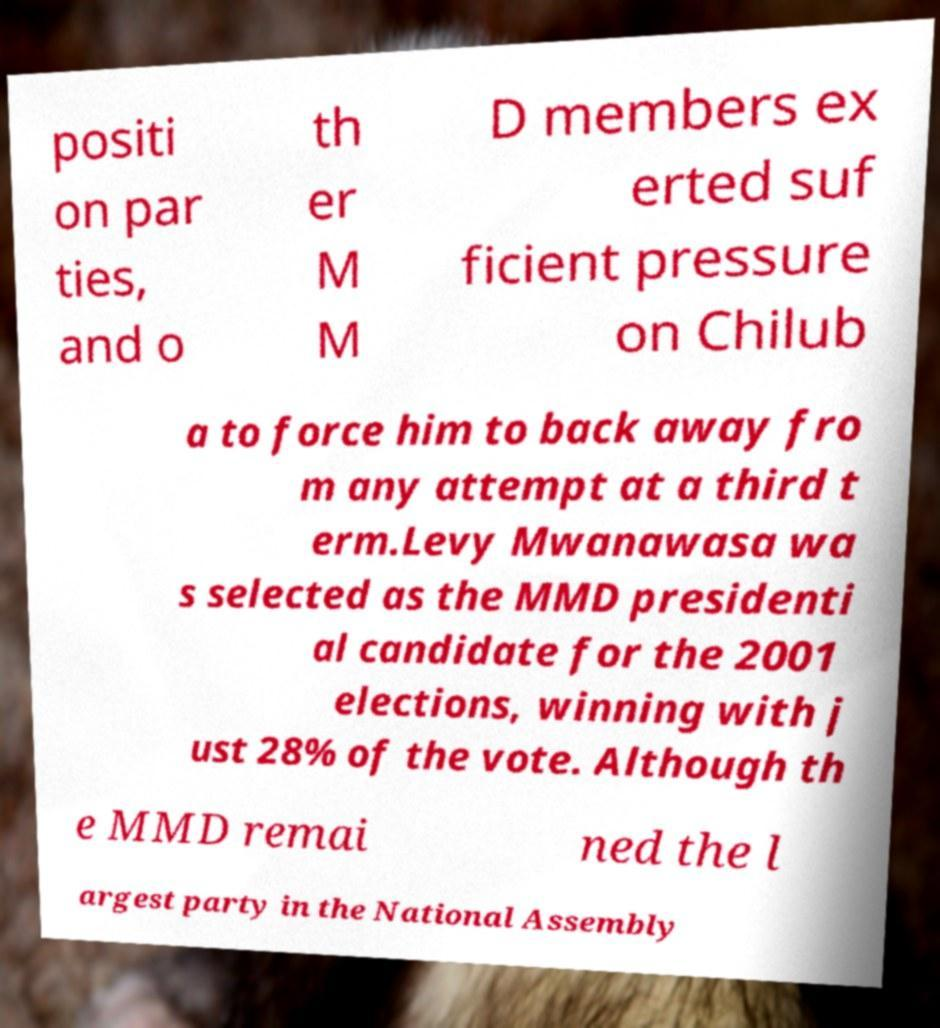There's text embedded in this image that I need extracted. Can you transcribe it verbatim? positi on par ties, and o th er M M D members ex erted suf ficient pressure on Chilub a to force him to back away fro m any attempt at a third t erm.Levy Mwanawasa wa s selected as the MMD presidenti al candidate for the 2001 elections, winning with j ust 28% of the vote. Although th e MMD remai ned the l argest party in the National Assembly 